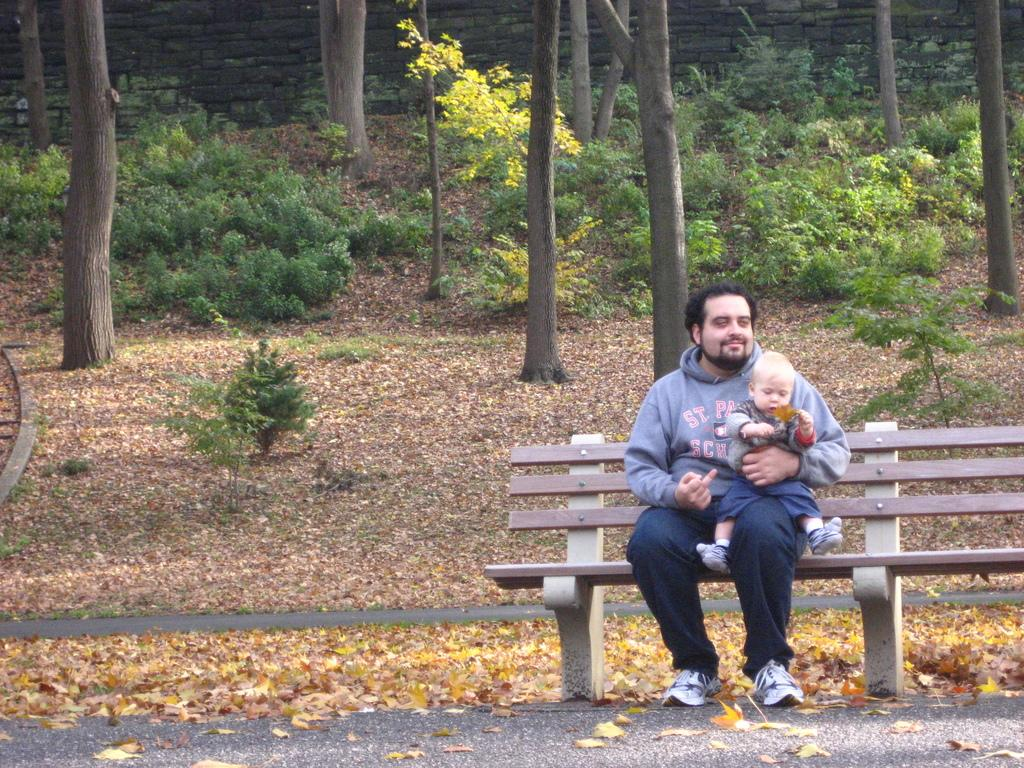Who is present in the image? There is a person and a baby in the image. What are they doing in the image? Both the person and the baby are sitting on a bench. What can be seen in the background of the image? There are plants, trees, grass, and leaves in the background of the image. What type of pen is the baby holding in the image? There is no pen present in the image; the baby is not holding anything. 